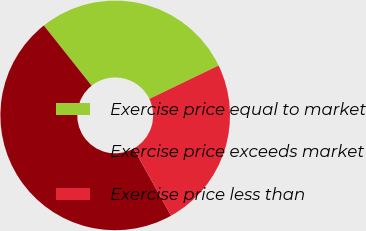Convert chart to OTSL. <chart><loc_0><loc_0><loc_500><loc_500><pie_chart><fcel>Exercise price equal to market<fcel>Exercise price exceeds market<fcel>Exercise price less than<nl><fcel>28.52%<fcel>47.41%<fcel>24.07%<nl></chart> 